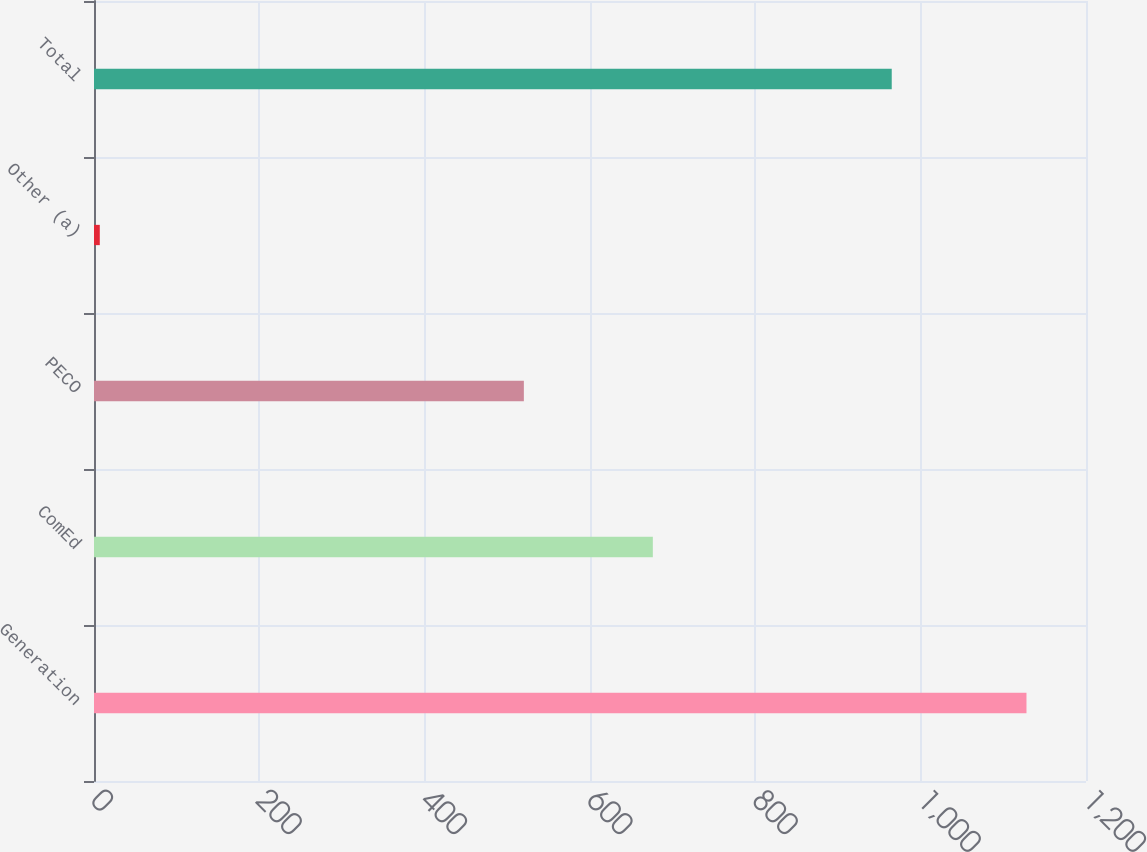Convert chart. <chart><loc_0><loc_0><loc_500><loc_500><bar_chart><fcel>Generation<fcel>ComEd<fcel>PECO<fcel>Other (a)<fcel>Total<nl><fcel>1128<fcel>676<fcel>520<fcel>7<fcel>965<nl></chart> 